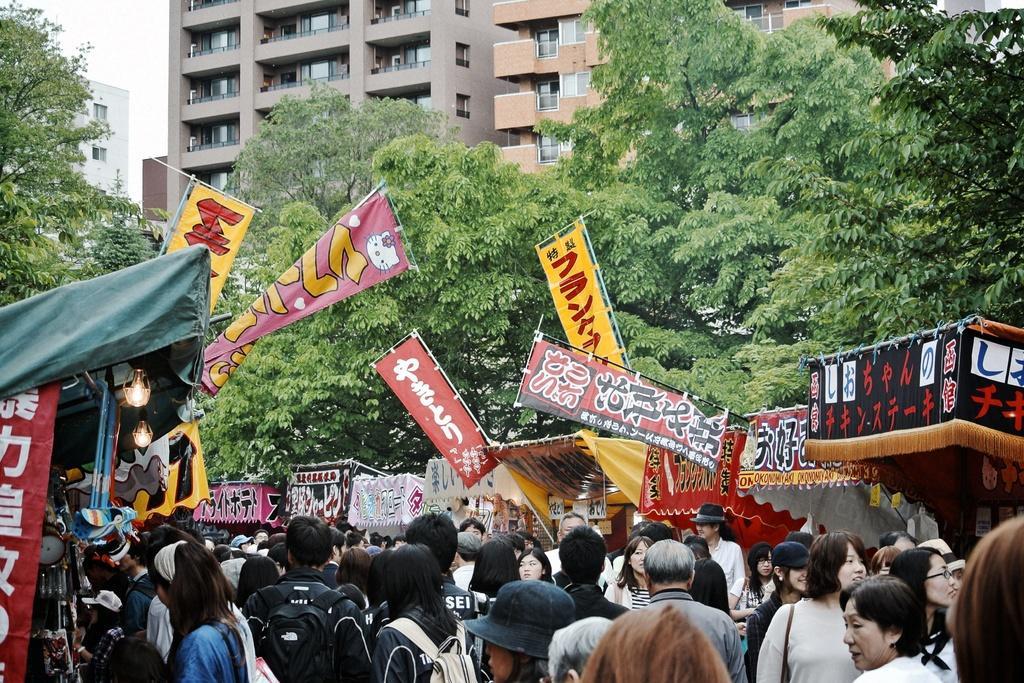Please provide a concise description of this image. In this image there are buildings truncated towards the top of the image, there is the sky, there is a building truncated towards the left of the image, there are trees, there are trees truncated towards the right of the image, there are trees truncated towards the left of the image, there are banners, there is text on the banners, there are lights, there are group of persons, there are persons truncated towards the bottom of the image, there is a person truncated towards the right of the image, there are objects truncated towards the left of the image. 